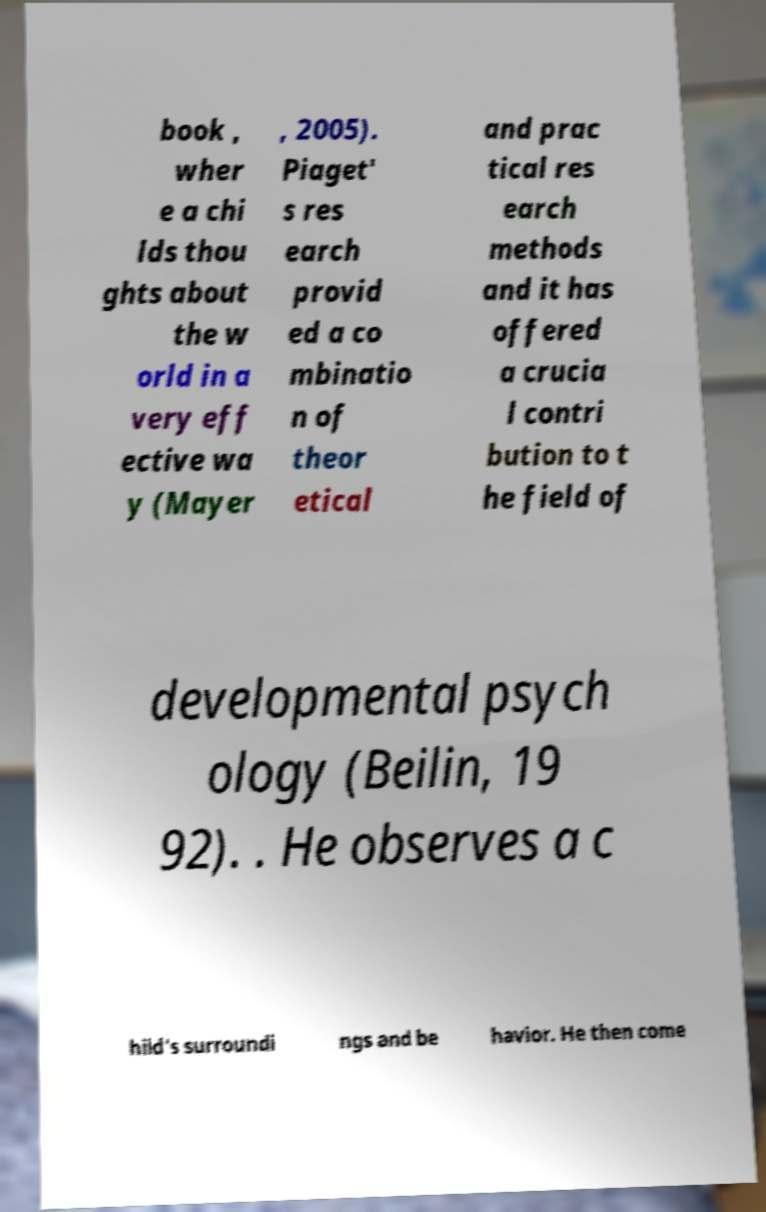Could you assist in decoding the text presented in this image and type it out clearly? book , wher e a chi lds thou ghts about the w orld in a very eff ective wa y (Mayer , 2005). Piaget' s res earch provid ed a co mbinatio n of theor etical and prac tical res earch methods and it has offered a crucia l contri bution to t he field of developmental psych ology (Beilin, 19 92). . He observes a c hild's surroundi ngs and be havior. He then come 